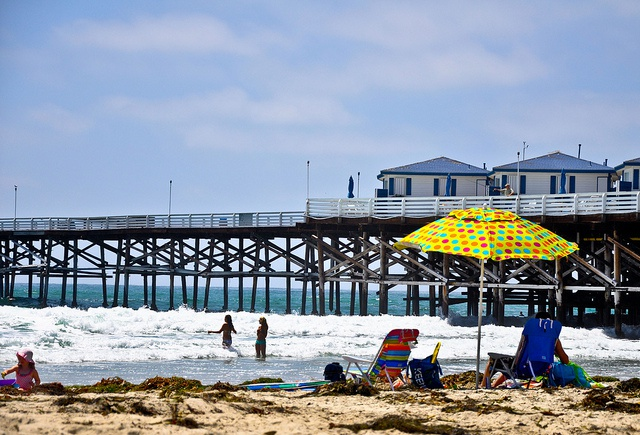Describe the objects in this image and their specific colors. I can see umbrella in gray, yellow, orange, black, and red tones, chair in gray, maroon, and olive tones, chair in gray, navy, black, and darkblue tones, people in gray, black, maroon, and navy tones, and backpack in gray, black, navy, and lightgray tones in this image. 